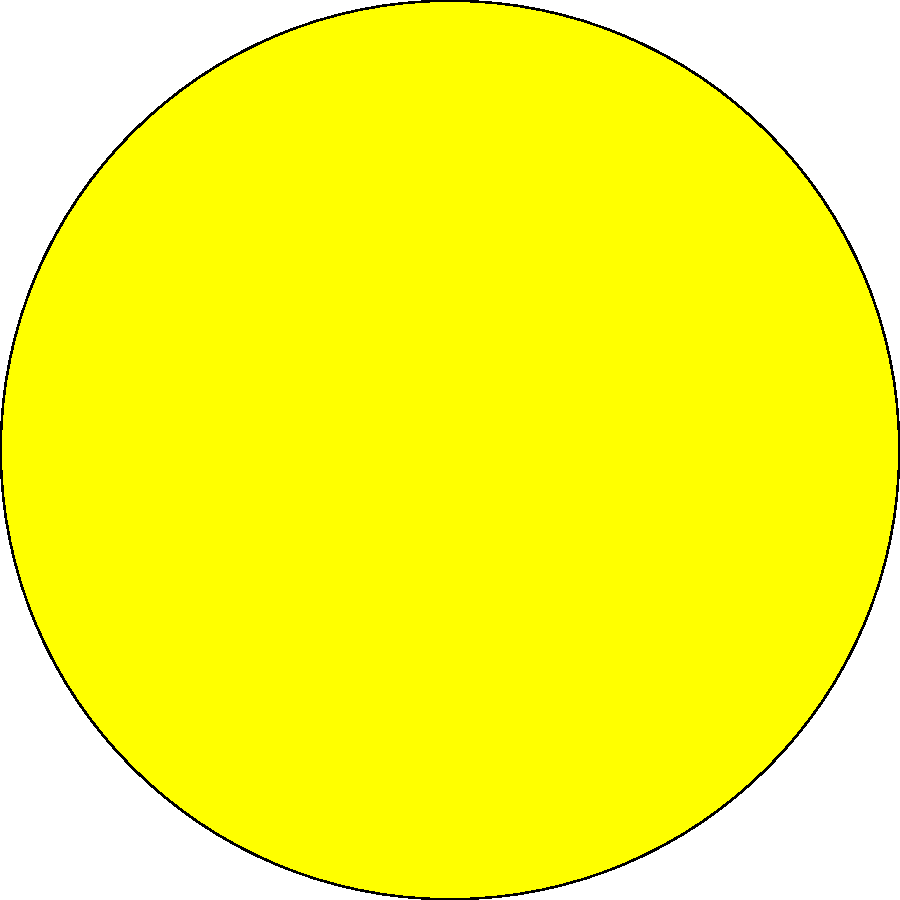In the series of illustrations above, which stage represents the moment of totality during a solar eclipse? To understand the stages of a solar eclipse, let's analyze each illustration:

1. Stage 1: The moon is just beginning to cover the sun. This is the partial eclipse phase, where the moon starts to cast its shadow on Earth.

2. Stage 2: The moon has covered a significant portion of the sun, but not entirely. This is still part of the partial eclipse phase, where the sun appears as a crescent.

3. Stage 3: The moon completely covers the sun's disk. This is the moment of totality, where the sun's corona becomes visible around the moon's silhouette.

4. Stage 4: The moon has begun to move away from the sun, revealing a portion of the sun's disk. This is the end of totality and the beginning of the second partial eclipse phase.

The moment of totality, when the moon fully covers the sun's disk, is represented in Stage 3. This is the most dramatic and brief part of a total solar eclipse, typically lasting only a few minutes.
Answer: Stage 3 